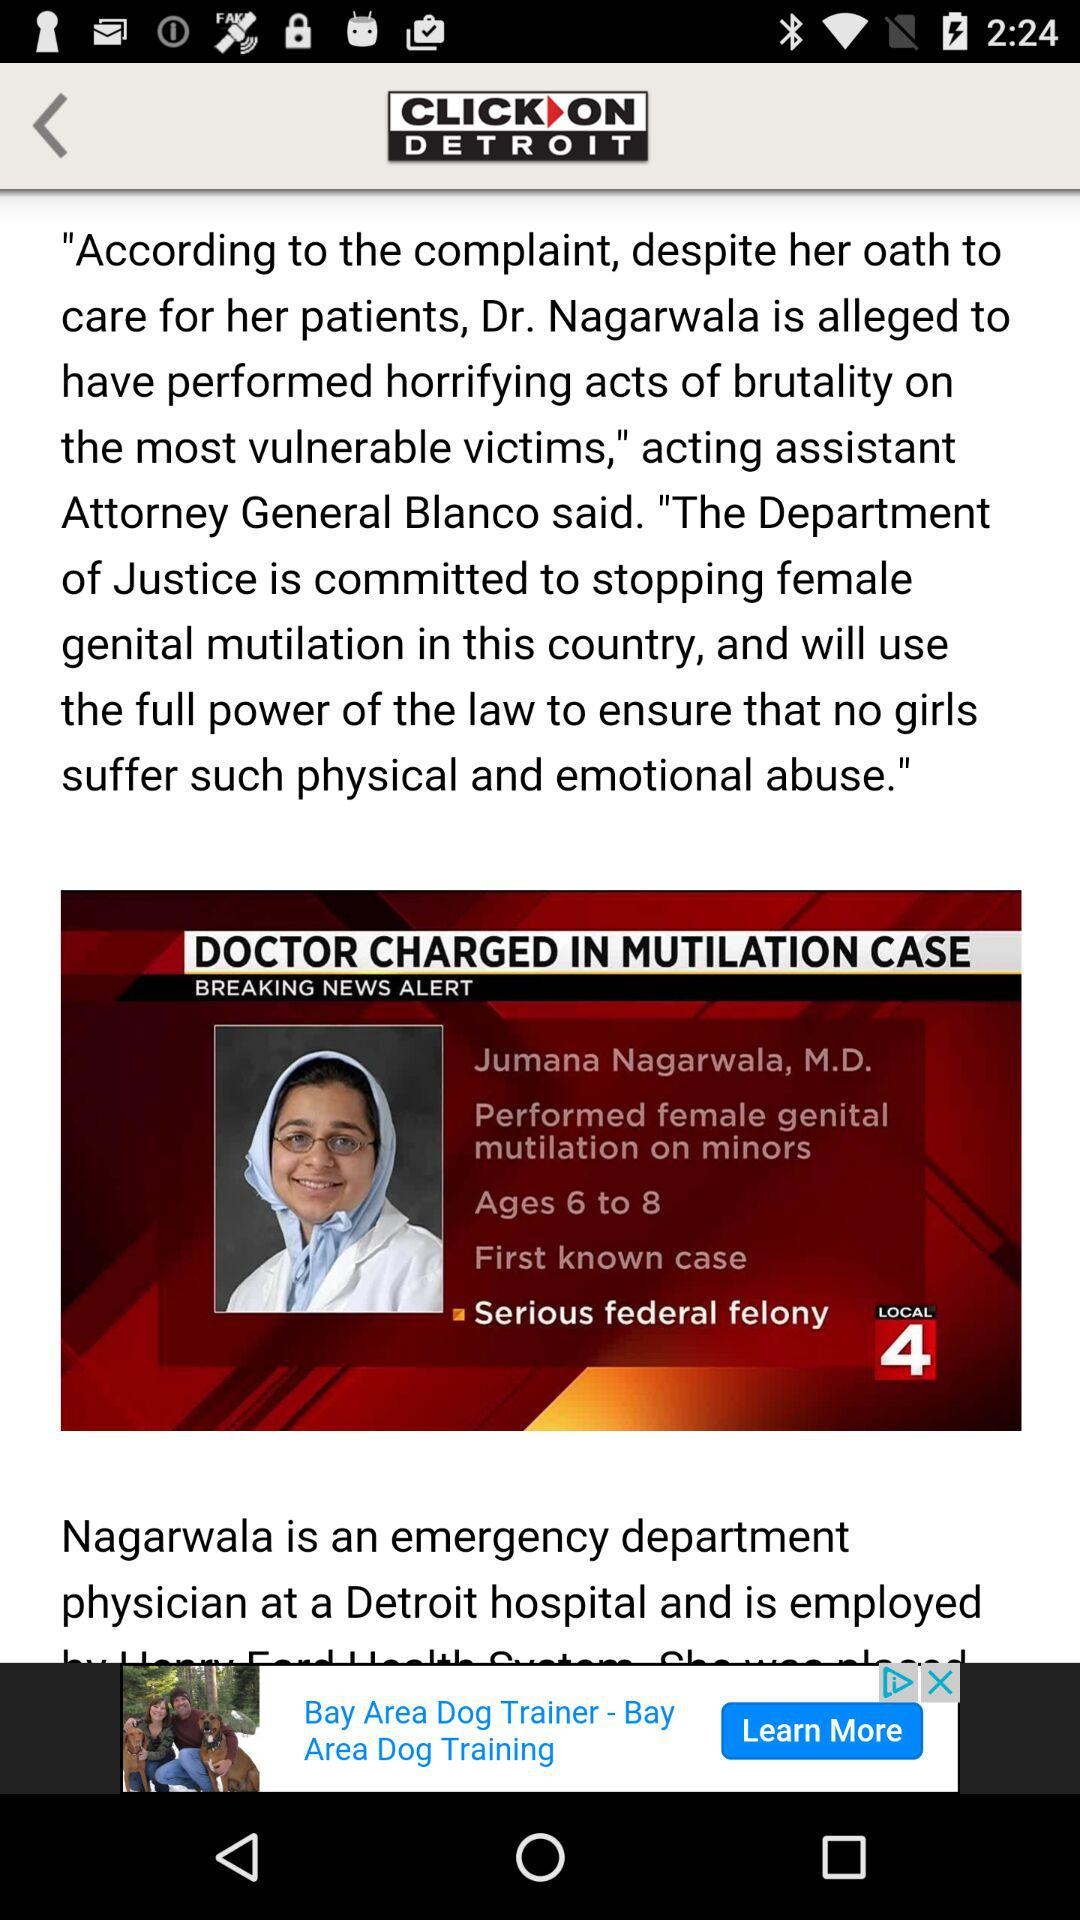Who performed female genital mutilation on minors? The person who performed female genital mutilation on minors is Jumana Nagarwala. 